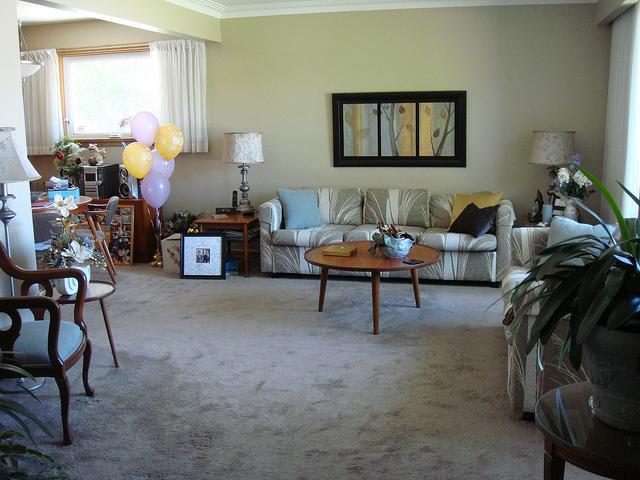What type of activity goes on at the tables?
Quick response, please. Sitting. IS the room white?
Answer briefly. Yes. Is this a hotel?
Short answer required. No. Is this room clean?
Answer briefly. Yes. What colors are the balloons?
Keep it brief. Pink and yellow. 